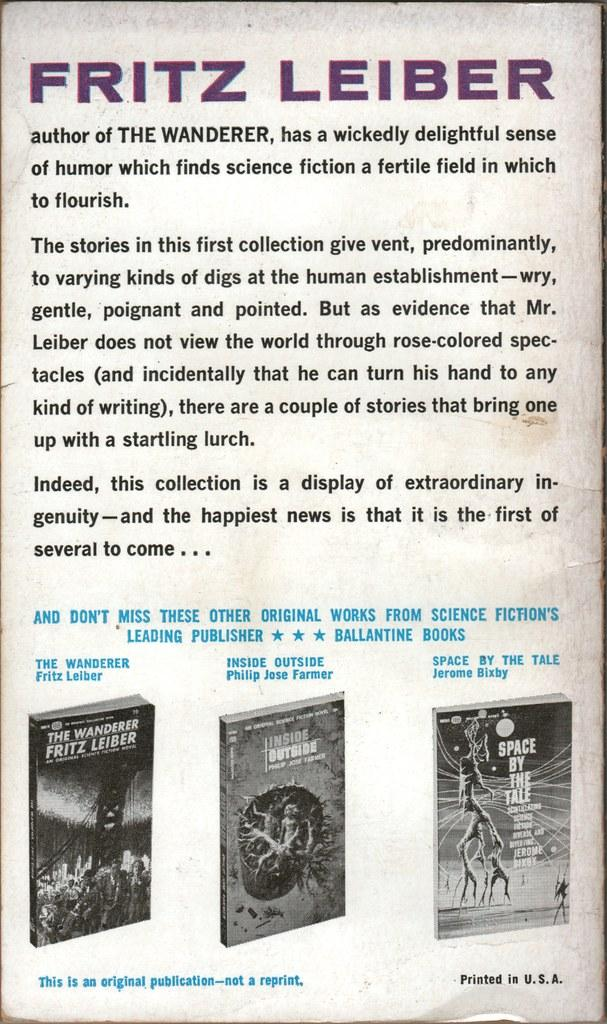<image>
Relay a brief, clear account of the picture shown. The back cover of a book talks about Fritz Leiber and his books that he has written, including the Wanderer. 